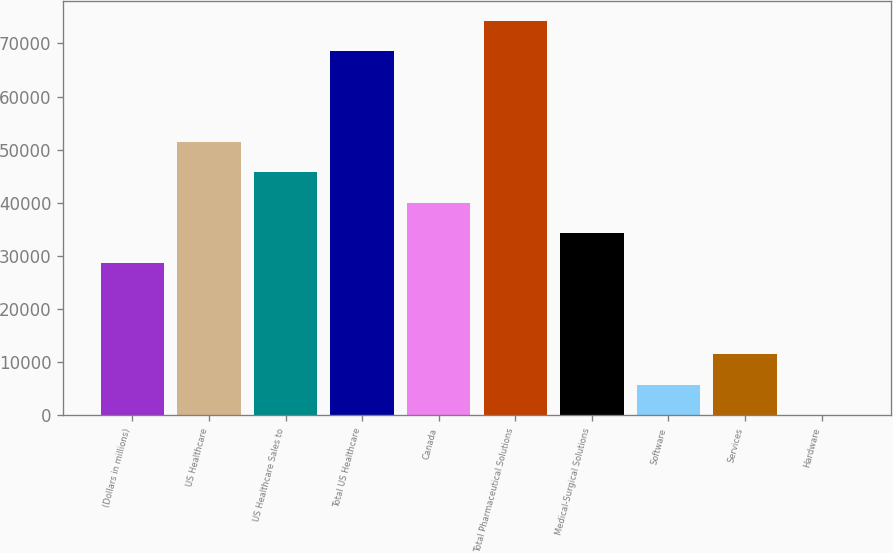Convert chart. <chart><loc_0><loc_0><loc_500><loc_500><bar_chart><fcel>(Dollars in millions)<fcel>US Healthcare<fcel>US Healthcare Sales to<fcel>Total US Healthcare<fcel>Canada<fcel>Total Pharmaceutical Solutions<fcel>Medical-Surgical Solutions<fcel>Software<fcel>Services<fcel>Hardware<nl><fcel>28610.9<fcel>51418.8<fcel>45716.8<fcel>68524.8<fcel>40014.9<fcel>74226.7<fcel>34312.9<fcel>5802.98<fcel>11505<fcel>101<nl></chart> 